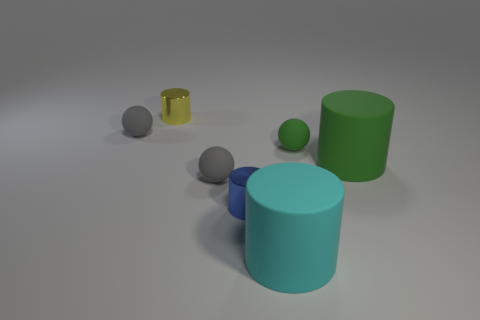Is the material of the small yellow thing behind the cyan matte object the same as the ball that is on the right side of the tiny blue cylinder?
Give a very brief answer. No. Are there more tiny gray matte things than blue things?
Provide a short and direct response. Yes. Are the small blue cylinder and the small yellow object made of the same material?
Provide a succinct answer. Yes. Are there fewer yellow shiny cylinders than green matte things?
Your answer should be very brief. Yes. Does the cyan matte object have the same shape as the yellow object?
Give a very brief answer. Yes. How many other objects are there of the same material as the big green cylinder?
Make the answer very short. 4. What number of blue objects are big cylinders or tiny objects?
Make the answer very short. 1. There is a small shiny thing that is on the right side of the small yellow cylinder; does it have the same shape as the tiny thing that is on the right side of the large cyan cylinder?
Provide a short and direct response. No. How many objects are either tiny green objects or rubber things that are right of the tiny yellow cylinder?
Provide a short and direct response. 4. What is the material of the cylinder that is on the left side of the cyan matte cylinder and in front of the tiny yellow metal thing?
Ensure brevity in your answer.  Metal. 